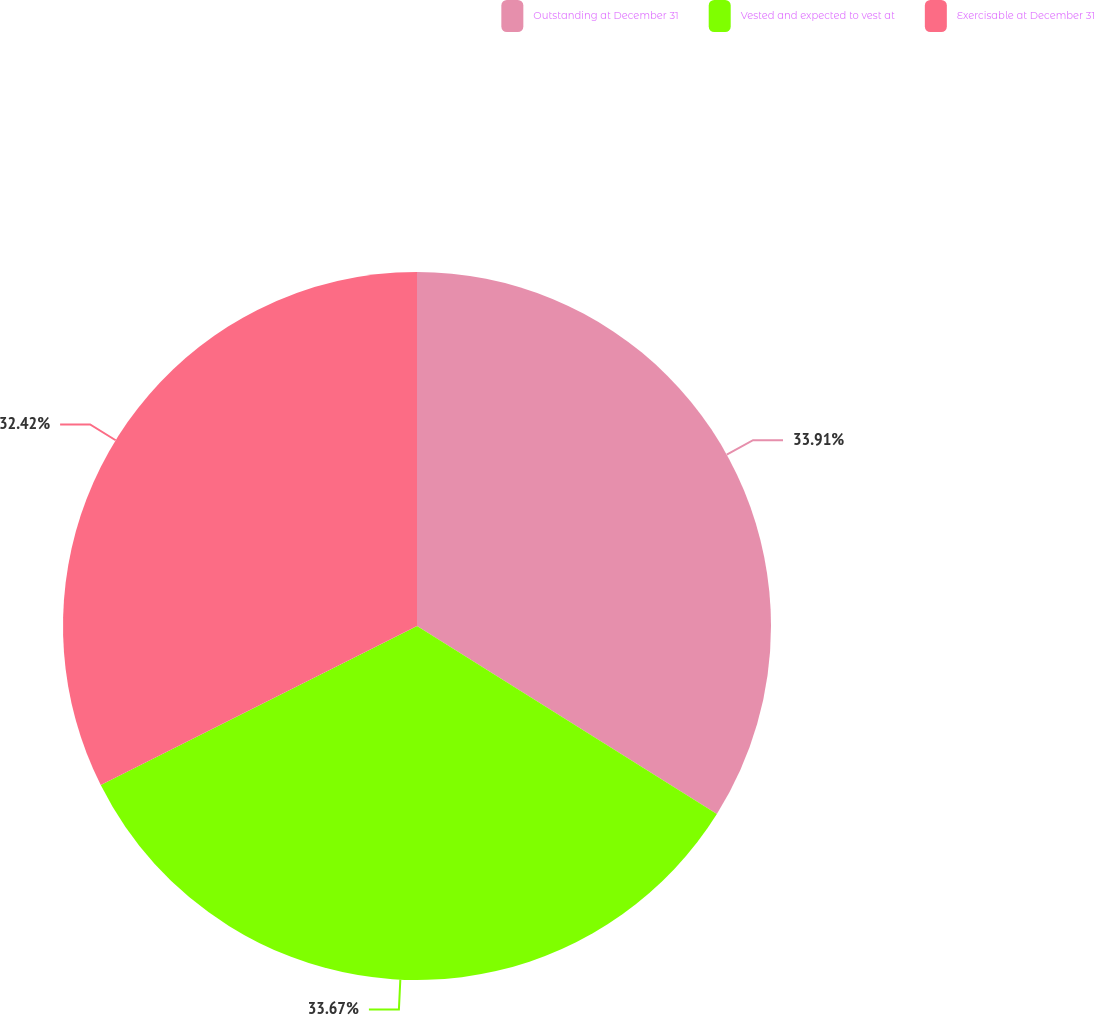Convert chart to OTSL. <chart><loc_0><loc_0><loc_500><loc_500><pie_chart><fcel>Outstanding at December 31<fcel>Vested and expected to vest at<fcel>Exercisable at December 31<nl><fcel>33.92%<fcel>33.67%<fcel>32.42%<nl></chart> 